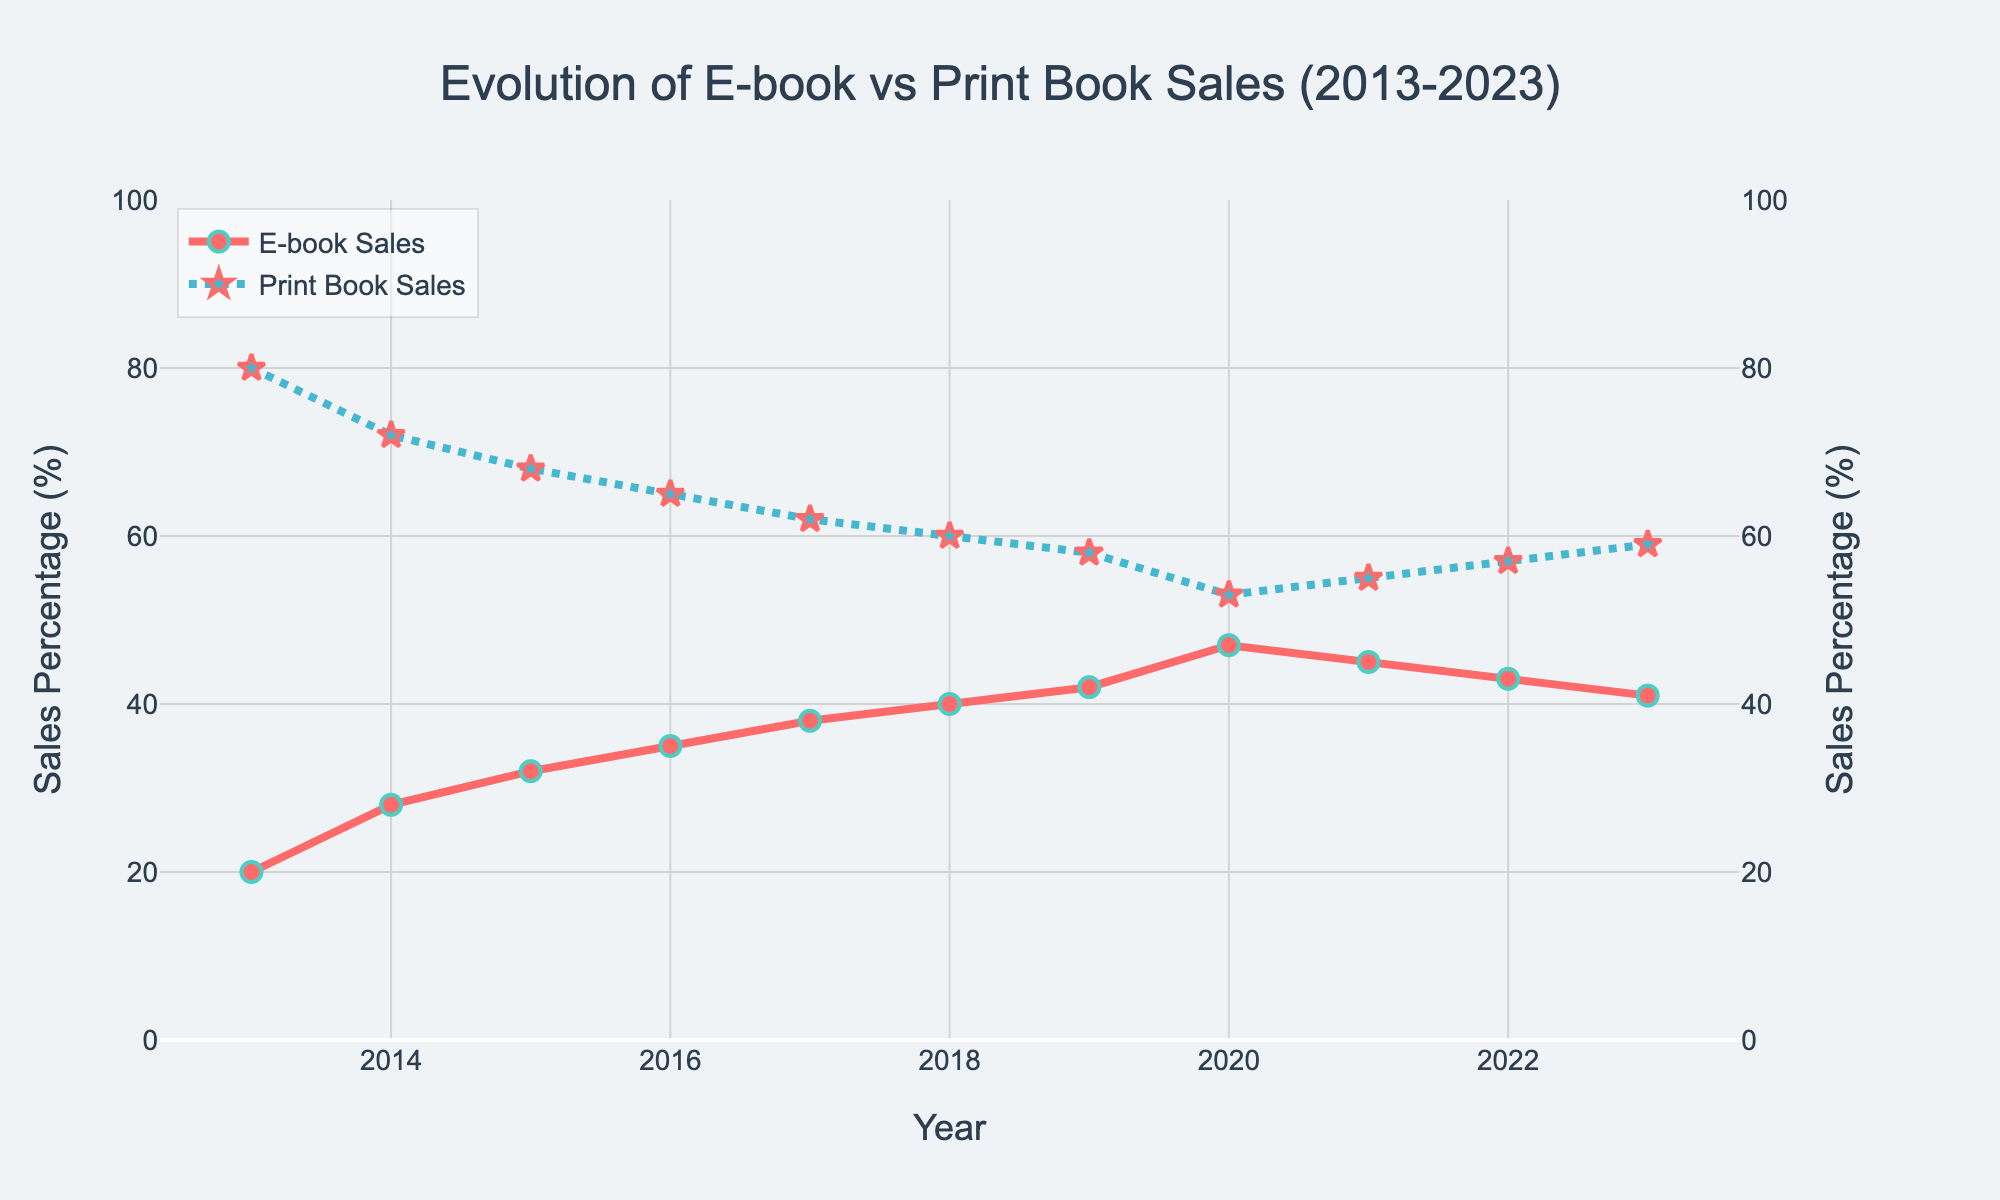What was the percentage growth in e-book sales from 2013 to 2020? To find the percentage growth, subtract the e-book sales percentage in 2013 from the percentage in 2020. The sales of e-books in 2013 were 20%, and in 2020 were 47%. The difference is 47% - 20% = 27%.
Answer: 27% In which year did e-book sales reach their peak, and what was the percentage? Look at the line for e-book sales and find the highest point. The highest point occurs in 2020, where the e-book sales percentage is 47%.
Answer: 2020, 47% How do e-book sales in 2021 compare to 2020? Look at the percentages for e-book sales in 2021 and 2020. The e-book sales were 47% in 2020 and 45% in 2021. This means there was a decrease of 47% - 45% = 2%.
Answer: Decreased by 2% What was the combined percentage of print and e-book sales in 2018? Sum the percentages of print and e-book sales for 2018. The print book sales were 60%, and the e-book sales were 40%. Their sum is 60% + 40% = 100%.
Answer: 100% Which had a larger percentage decline over the decade, print or e-book sales? Calculate the percentage changes for both e-book and print book sales from 2013 to 2023. E-book sales increased from 20% to 41%, an increase of 21%. Print sales decreased from 80% to 59%, a decline of 21%. Therefore, the declines will be 0% and 21% respectively.
Answer: Print books, 21% What year had the smallest difference between e-book and print book sales percentages? Look at each year's data and calculate the differences between print and e-book sales. The smallest difference occurs in 2020, with a difference of 47% - 53% = 6%.
Answer: 2020 How did print book sales change from 2013 to 2023? Subtract the print book sales percentage in 2023 from 2013. The print book sales were 80% in 2013 and 59% in 2023. The difference is 80% - 59% = 21%.
Answer: Decreased by 21% In which year did print book sales fall below 60% for the first time? Identify the first year where the print book sales percentage is below 60%. It is in 2019, where the sales percentage is 58%.
Answer: 2019 